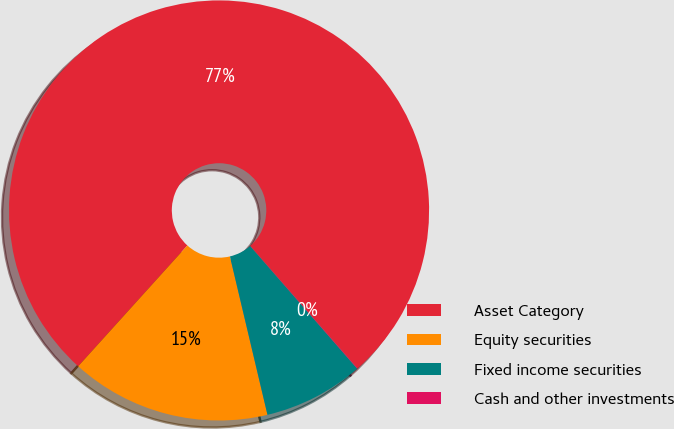Convert chart to OTSL. <chart><loc_0><loc_0><loc_500><loc_500><pie_chart><fcel>Asset Category<fcel>Equity securities<fcel>Fixed income securities<fcel>Cash and other investments<nl><fcel>76.84%<fcel>15.4%<fcel>7.72%<fcel>0.04%<nl></chart> 